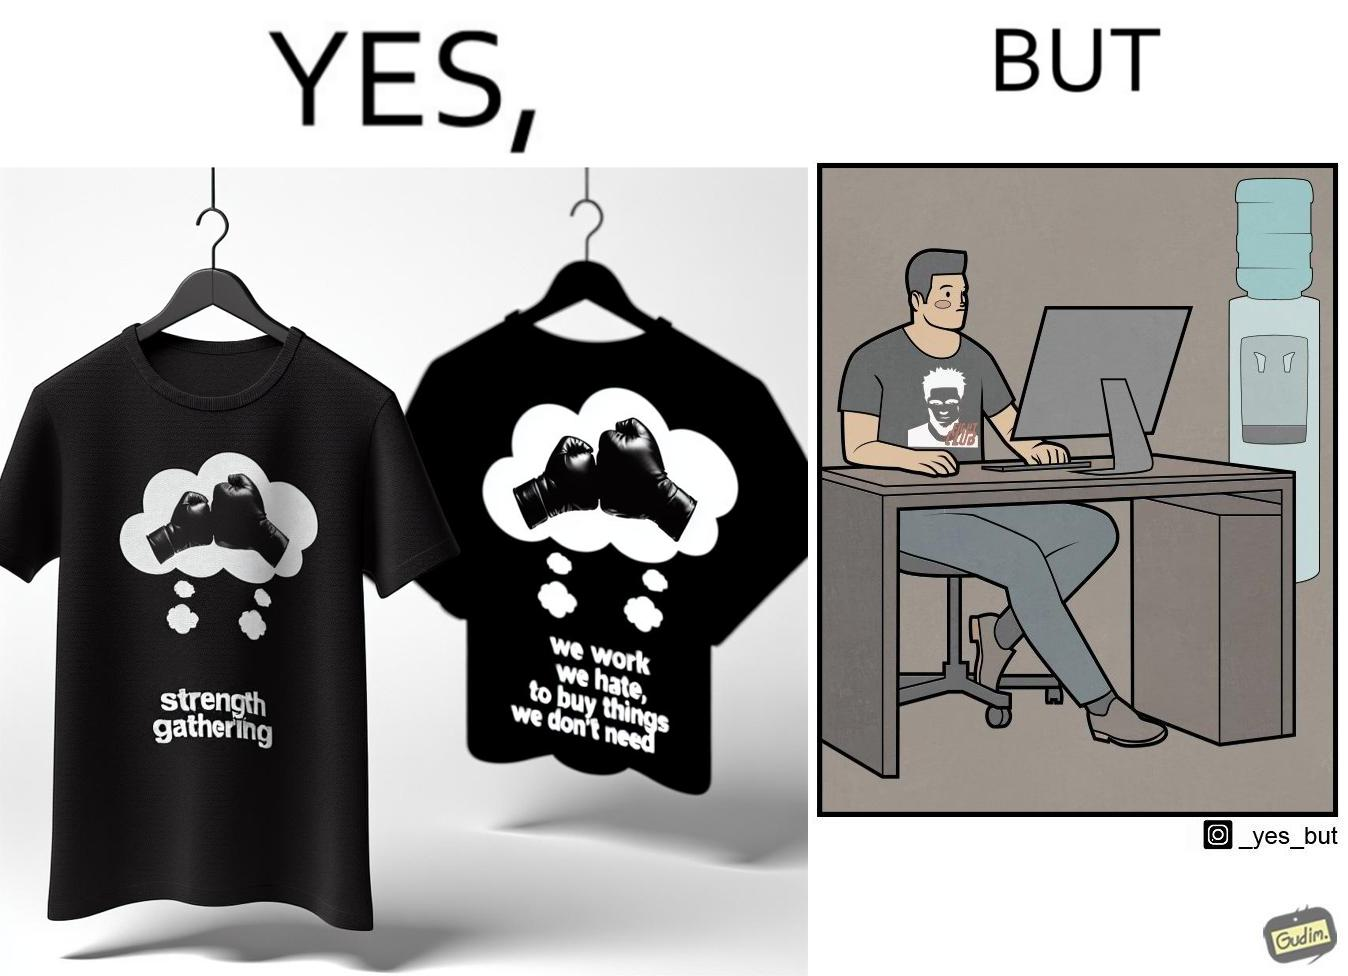What do you see in each half of this image? In the left part of the image: a t-shirt with "Fight Club" written on it (referring to the movie), along with a dialogue from the movie that says "We work jobs we hate, to buy sh*t we don't need". In the right part of the image: a person wearing a t-shirt that says "Fight Club", working on a computer system, with a water dispenser by the side. 